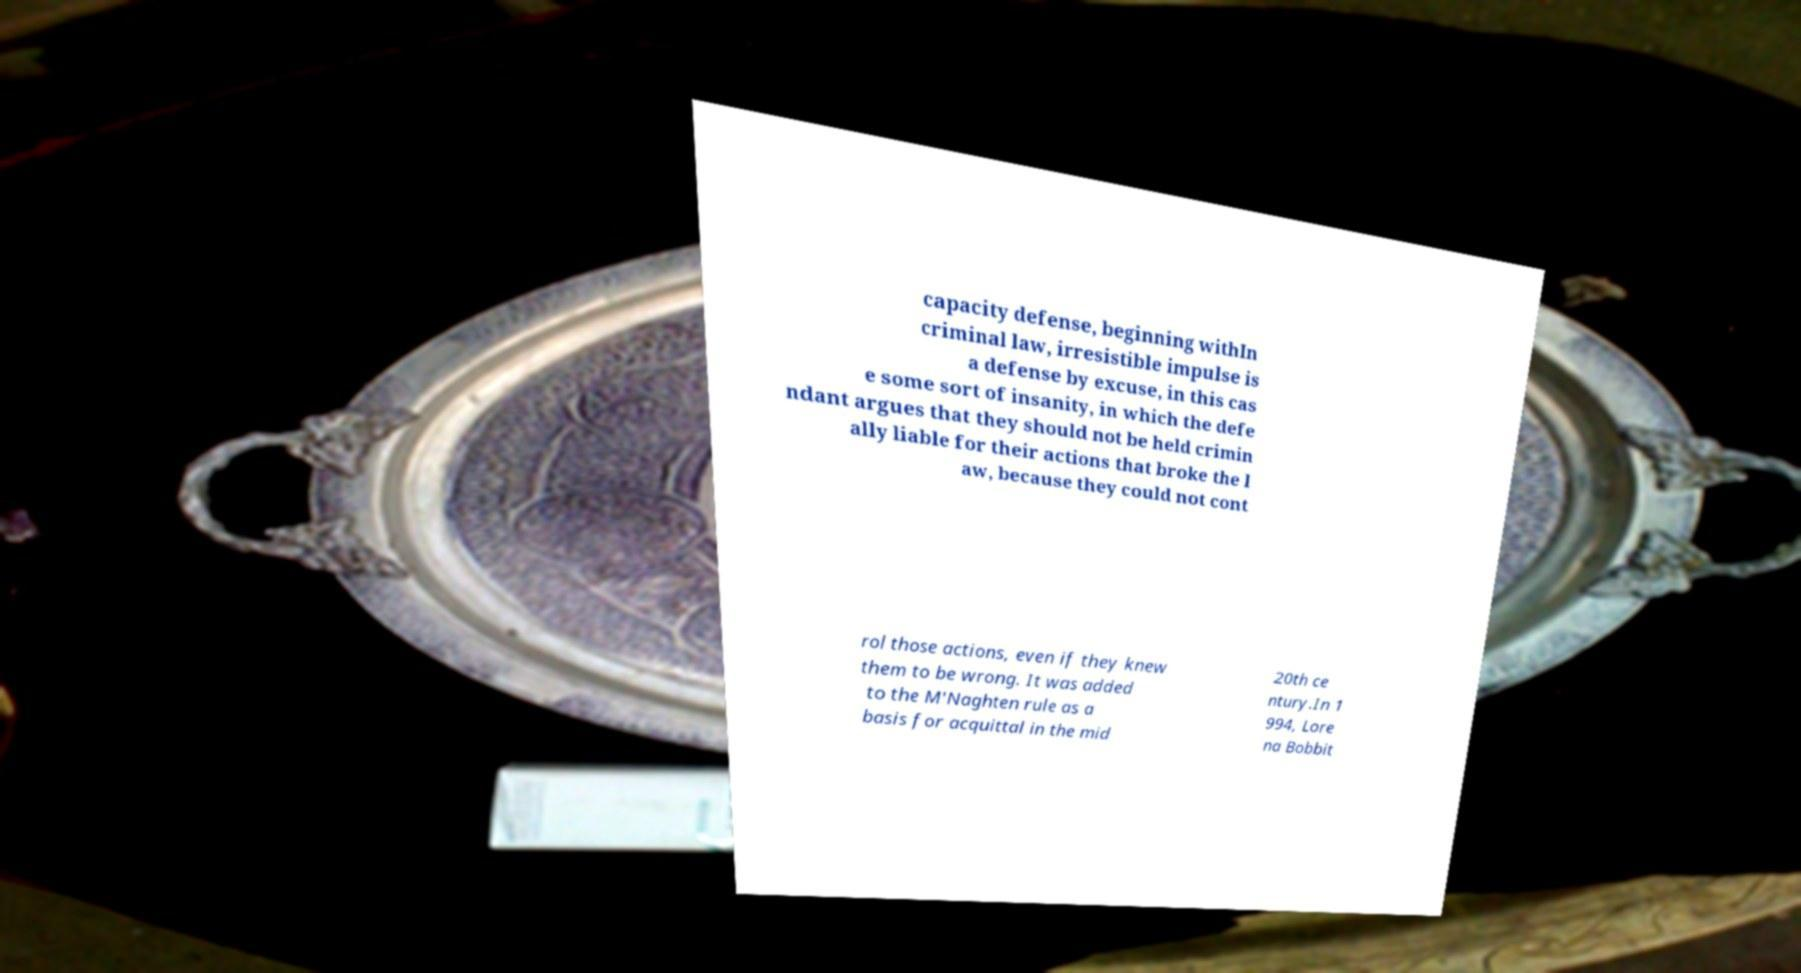I need the written content from this picture converted into text. Can you do that? capacity defense, beginning withIn criminal law, irresistible impulse is a defense by excuse, in this cas e some sort of insanity, in which the defe ndant argues that they should not be held crimin ally liable for their actions that broke the l aw, because they could not cont rol those actions, even if they knew them to be wrong. It was added to the M'Naghten rule as a basis for acquittal in the mid 20th ce ntury.In 1 994, Lore na Bobbit 